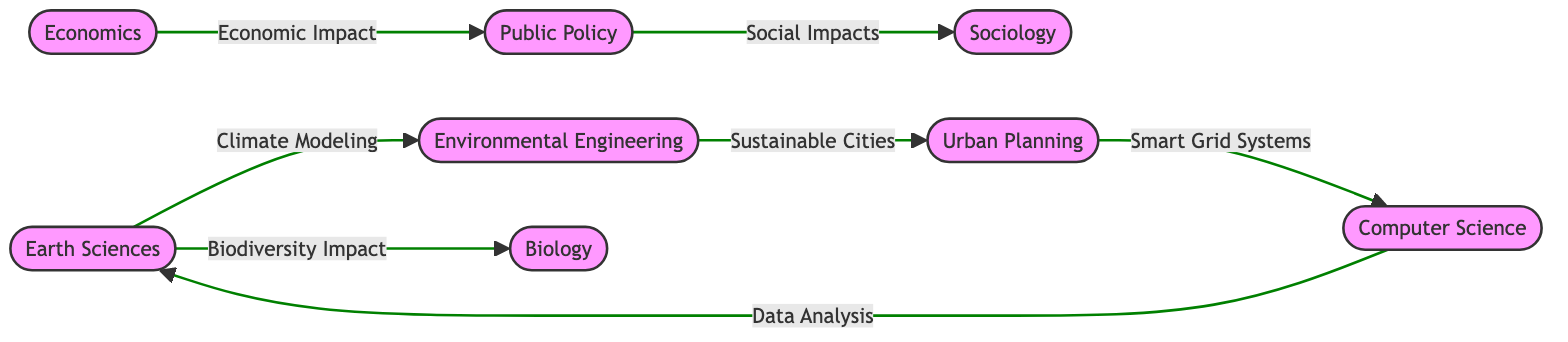What is the total number of departments represented in the diagram? The diagram has a total of eight nodes, each representing a different department involved in climate research.
Answer: 8 Which department collaborates with the Earth Sciences Department on climate modeling? The edge labeled "Climate Modeling" connects the Earth Sciences Department to the Environmental Engineering Department, indicating that they collaborate on this research area.
Answer: Environmental Engineering Department What is the relationship between the Economics Department and the Public Policy Department? The arrow indicates a one-way collaboration from the Economics Department to the Public Policy Department labeled "Economic Impact of Climate Policies," showing their relationship in research proposals.
Answer: Economic Impact of Climate Policies How many collaborations are connected to the Sociology Department? There is only one directed edge pointing from the Public Policy Department to the Sociology Department labeled "Social Impacts of Climate Regulations," indicating a single collaboration.
Answer: 1 Which two departments are connected by the edge labeled "Sustainable City Designs"? The edge labeled "Sustainable City Designs" is directed from the Environmental Engineering Department to the Urban Planning Department, indicating a collaborative effort between these two departments.
Answer: Environmental Engineering Department and Urban Planning Department What type of collaboration is shown between the Urban Planning Department and the Computer Science Department? The collaboration is focused on "Smart Grid and Renewable Energy Systems," as indicated by the directed edge connecting the Urban Planning Department to the Computer Science Department.
Answer: Smart Grid and Renewable Energy Systems Which department has the most outgoing collaborations based on the directed edges in the diagram? By examining the edges, the Earth Sciences Department has two outgoing edges (to Environmental Engineering and Biology Departments), which is more than any other department in the diagram.
Answer: Earth Sciences Department Are there any collaborations leading back to the Earth Sciences Department? Yes, there is an edge from the Computer Science Department directed back to the Earth Sciences Department labeled "Climate Data Analysis," indicating a return collaboration.
Answer: Yes 